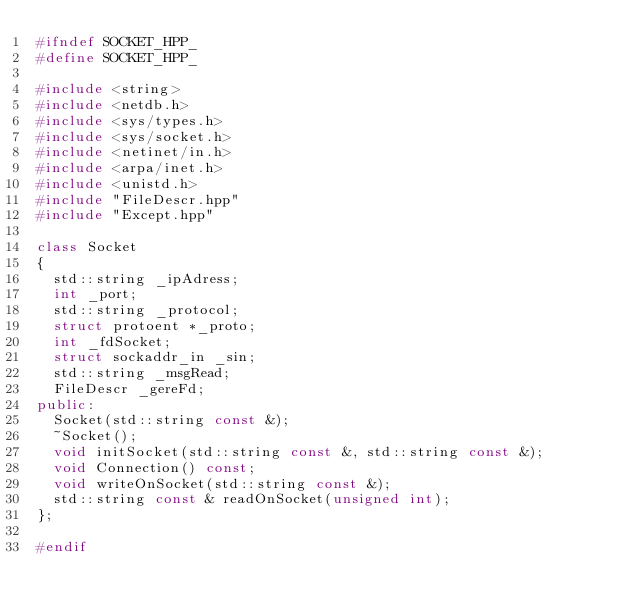Convert code to text. <code><loc_0><loc_0><loc_500><loc_500><_C++_>#ifndef SOCKET_HPP_
#define SOCKET_HPP_

#include <string>
#include <netdb.h>
#include <sys/types.h>
#include <sys/socket.h>
#include <netinet/in.h>
#include <arpa/inet.h>
#include <unistd.h>
#include "FileDescr.hpp"
#include "Except.hpp"

class Socket
{
  std::string _ipAdress;
  int _port;
  std::string _protocol;
  struct protoent *_proto;
  int _fdSocket;
  struct sockaddr_in _sin;
  std::string _msgRead;
  FileDescr _gereFd;
public:
  Socket(std::string const &);
  ~Socket();
  void initSocket(std::string const &, std::string const &);
  void Connection() const;
  void writeOnSocket(std::string const &);
  std::string const & readOnSocket(unsigned int);
};

#endif
</code> 